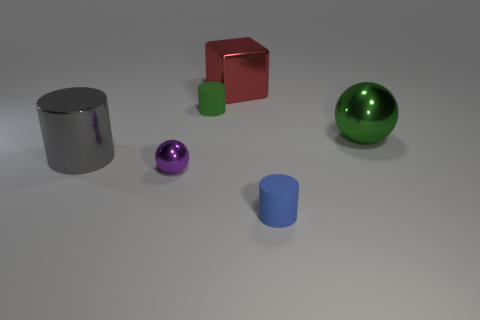Imagine this is a physics demonstration, what principle could it be illustrating? If we imagine this as a physics demonstration, it might be illustrating principles of material density and balance. The difference in materials, such as the heavier metal sphere versus the lighter rubber cylinder, could imply experiments on how different materials interact with the same gravitational forces or are balanced on a flat surface. The arrangement may also prompt discussions about center of mass and stability. 